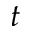<formula> <loc_0><loc_0><loc_500><loc_500>t</formula> 